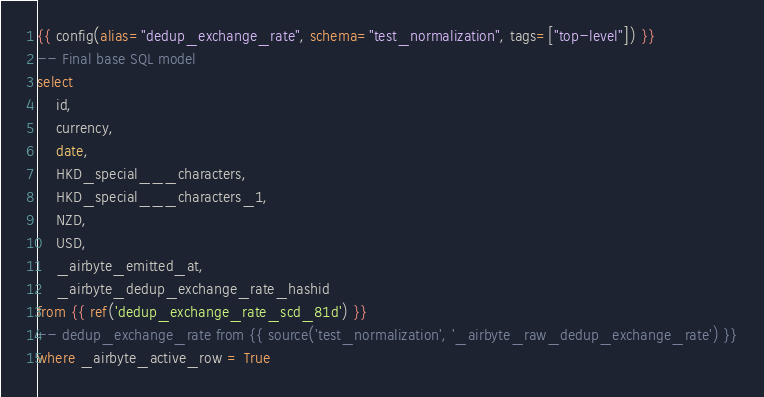Convert code to text. <code><loc_0><loc_0><loc_500><loc_500><_SQL_>{{ config(alias="dedup_exchange_rate", schema="test_normalization", tags=["top-level"]) }}
-- Final base SQL model
select
    id,
    currency,
    date,
    HKD_special___characters,
    HKD_special___characters_1,
    NZD,
    USD,
    _airbyte_emitted_at,
    _airbyte_dedup_exchange_rate_hashid
from {{ ref('dedup_exchange_rate_scd_81d') }}
-- dedup_exchange_rate from {{ source('test_normalization', '_airbyte_raw_dedup_exchange_rate') }}
where _airbyte_active_row = True

</code> 